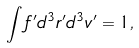Convert formula to latex. <formula><loc_0><loc_0><loc_500><loc_500>\int { f ^ { \prime } } d ^ { 3 } { r } ^ { \prime } d ^ { 3 } { v } ^ { \prime } = 1 ,</formula> 